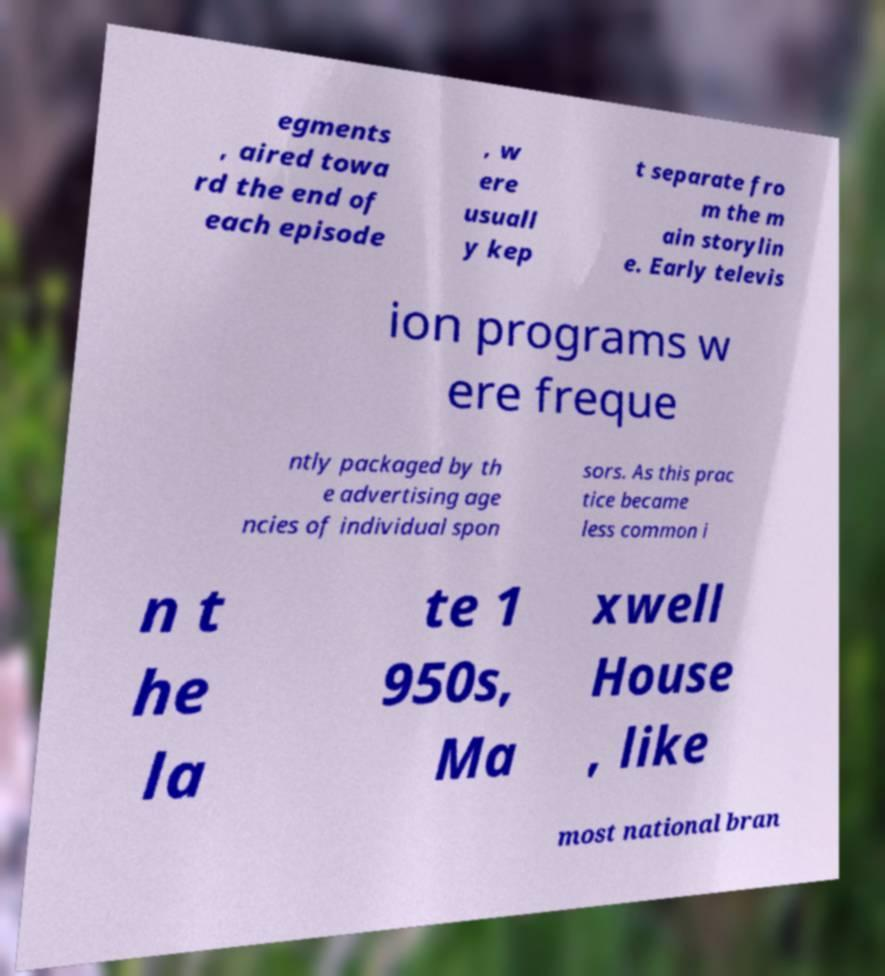What messages or text are displayed in this image? I need them in a readable, typed format. egments , aired towa rd the end of each episode , w ere usuall y kep t separate fro m the m ain storylin e. Early televis ion programs w ere freque ntly packaged by th e advertising age ncies of individual spon sors. As this prac tice became less common i n t he la te 1 950s, Ma xwell House , like most national bran 